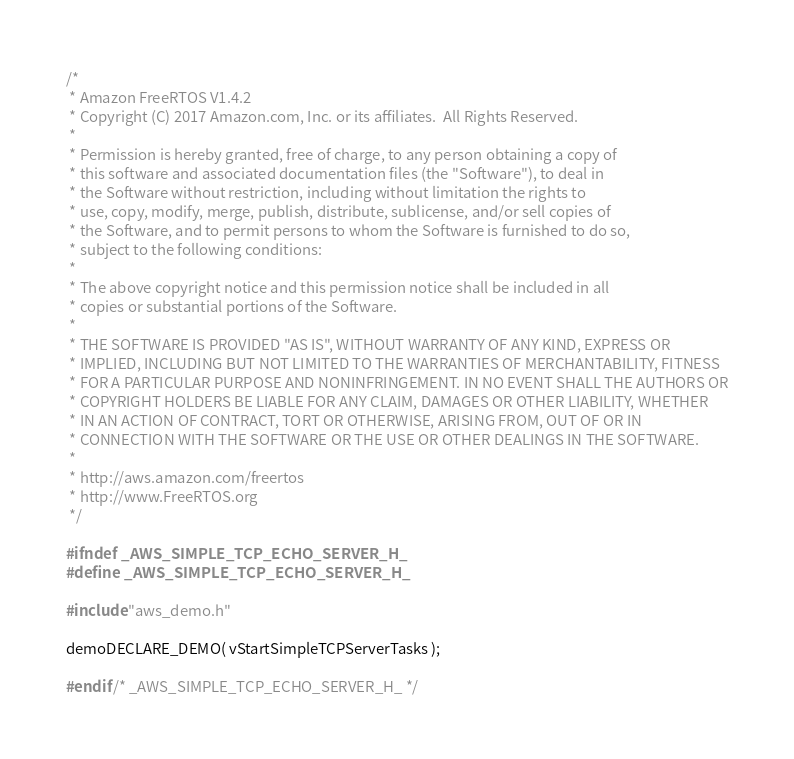<code> <loc_0><loc_0><loc_500><loc_500><_C_>/*
 * Amazon FreeRTOS V1.4.2
 * Copyright (C) 2017 Amazon.com, Inc. or its affiliates.  All Rights Reserved.
 *
 * Permission is hereby granted, free of charge, to any person obtaining a copy of
 * this software and associated documentation files (the "Software"), to deal in
 * the Software without restriction, including without limitation the rights to
 * use, copy, modify, merge, publish, distribute, sublicense, and/or sell copies of
 * the Software, and to permit persons to whom the Software is furnished to do so,
 * subject to the following conditions:
 *
 * The above copyright notice and this permission notice shall be included in all
 * copies or substantial portions of the Software.
 *
 * THE SOFTWARE IS PROVIDED "AS IS", WITHOUT WARRANTY OF ANY KIND, EXPRESS OR
 * IMPLIED, INCLUDING BUT NOT LIMITED TO THE WARRANTIES OF MERCHANTABILITY, FITNESS
 * FOR A PARTICULAR PURPOSE AND NONINFRINGEMENT. IN NO EVENT SHALL THE AUTHORS OR
 * COPYRIGHT HOLDERS BE LIABLE FOR ANY CLAIM, DAMAGES OR OTHER LIABILITY, WHETHER
 * IN AN ACTION OF CONTRACT, TORT OR OTHERWISE, ARISING FROM, OUT OF OR IN
 * CONNECTION WITH THE SOFTWARE OR THE USE OR OTHER DEALINGS IN THE SOFTWARE.
 *
 * http://aws.amazon.com/freertos
 * http://www.FreeRTOS.org
 */

#ifndef _AWS_SIMPLE_TCP_ECHO_SERVER_H_
#define _AWS_SIMPLE_TCP_ECHO_SERVER_H_

#include "aws_demo.h"

demoDECLARE_DEMO( vStartSimpleTCPServerTasks );

#endif /* _AWS_SIMPLE_TCP_ECHO_SERVER_H_ */
</code> 